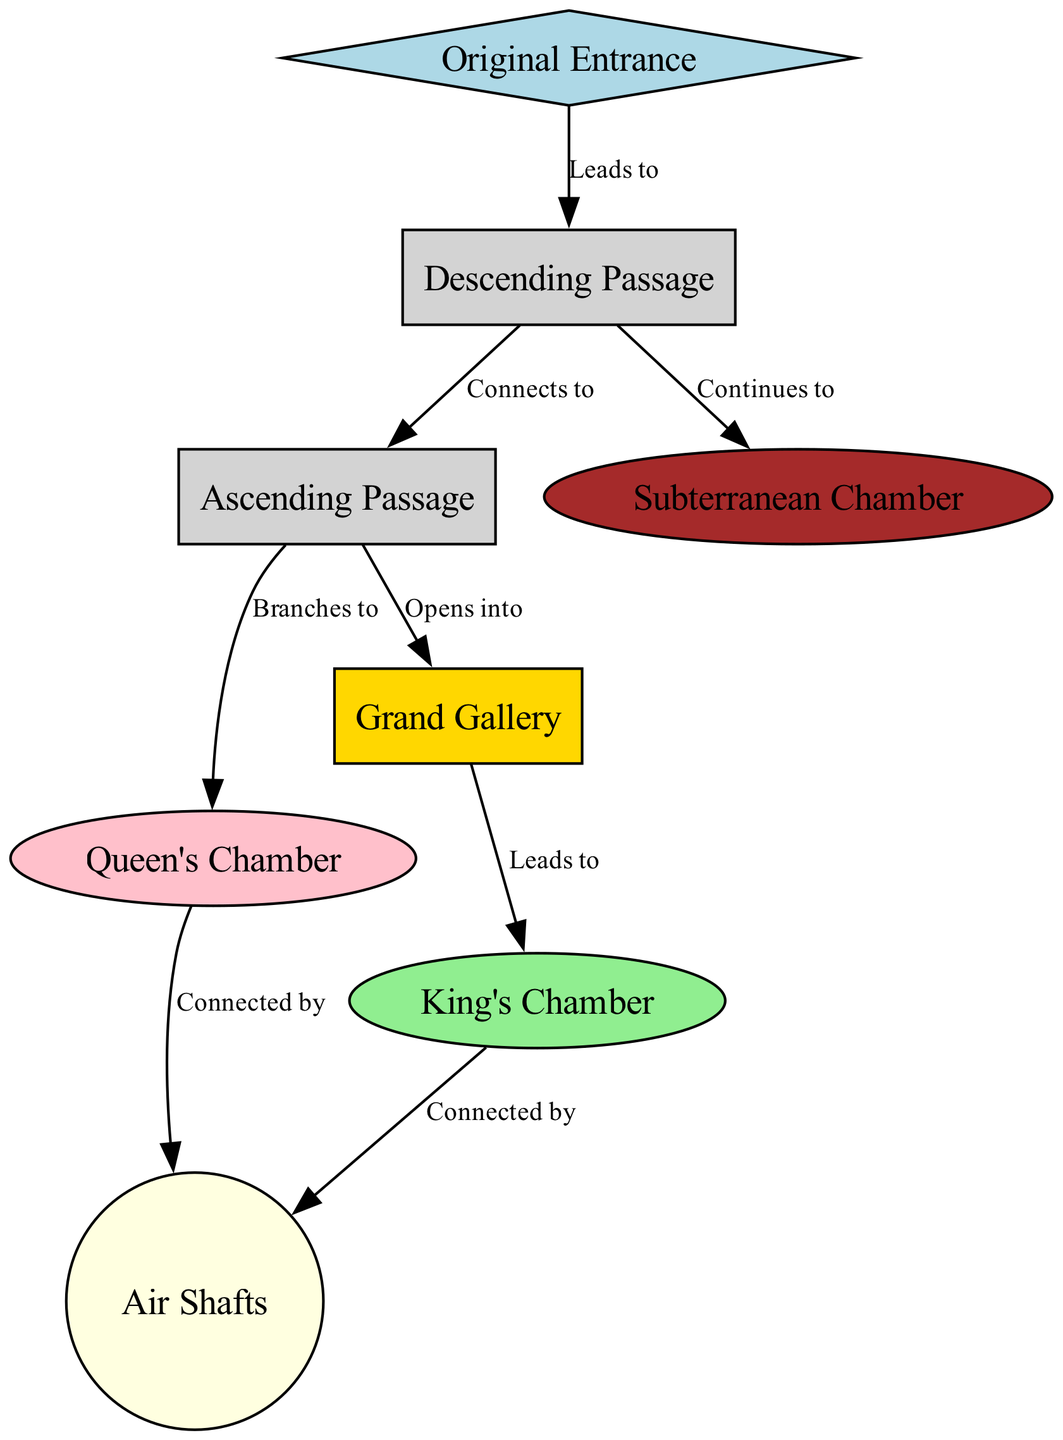What is the starting point of the internal structure? The diagram indicates that the starting point of the internal structure is labeled as the "Original Entrance," from which the first passage begins.
Answer: Original Entrance How many chambers are depicted in the diagram? By counting the nodes labeled as chambers, we find there are four: Queen's Chamber, King's Chamber, Subterranean Chamber, and one additional labeled Grand Gallery.
Answer: Four What pathway connects the Descending Passage to the Subterranean Chamber? The diagram shows a direct connection from the "Descending Passage" leading to the "Subterranean Chamber." This indicates the path continues from the descending passage to this chamber.
Answer: Continues to Which chamber is connected by air shafts to both the King's Chamber and Queen's Chamber? The diagram reveals that both the "King's Chamber" and "Queen's Chamber" are connected by "Air Shafts," indicating their ventilation pathways share this same connection.
Answer: Air Shafts What two pathways branch from the Ascending Passage? The Ascending Passage branches into two paths. One leads to the Grand Gallery and the other leads to the Queen's Chamber. This division indicates there are two distinct routes from the Ascending Passage.
Answer: Grand Gallery and Queen's Chamber How does the Grand Gallery relate to the King's Chamber? The Grand Gallery leads directly to the King's Chamber, showcasing it as the next structural element after traversing the Grand Gallery. This confirms the flow from one significant chamber to another.
Answer: Leads to What is the shape of the Queen's Chamber in the diagram? The Queen's Chamber is represented as an ellipse according to the diagram's design, which gives it a distinct visual representation compared to the other components.
Answer: Ellipse What type of passage begins at the Original Entrance? The passage beginning at the Original Entrance is titled the "Descending Passage," indicating it moves downward into the structure. This establishes the initial transition into the pyramid's interior.
Answer: Descending Passage Which chamber appears directly after the Ascending Passage? Following the Ascending Passage, the structure opens into the Grand Gallery as the next significant area that is reached after ascending. This shows the upward progression through the pyramid's geometry.
Answer: Grand Gallery 